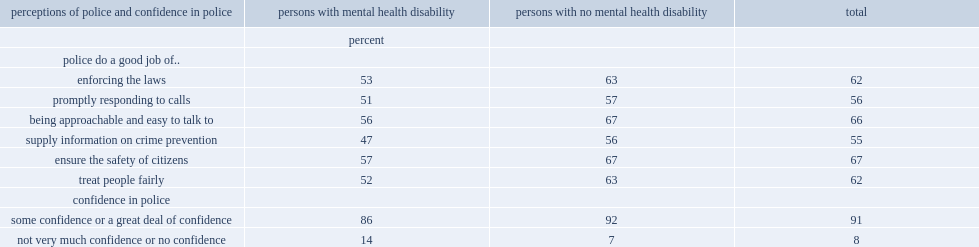Which group of people is less likely to say that police were doing a good job at enforcing the laws, people with disabilities related to mental health or people with no disabilities related to mental health? Persons with mental health disability. How many times is persons with mental health disability to say that they have not very much or no confidence in the police than persons with no mental health disability? 2. 